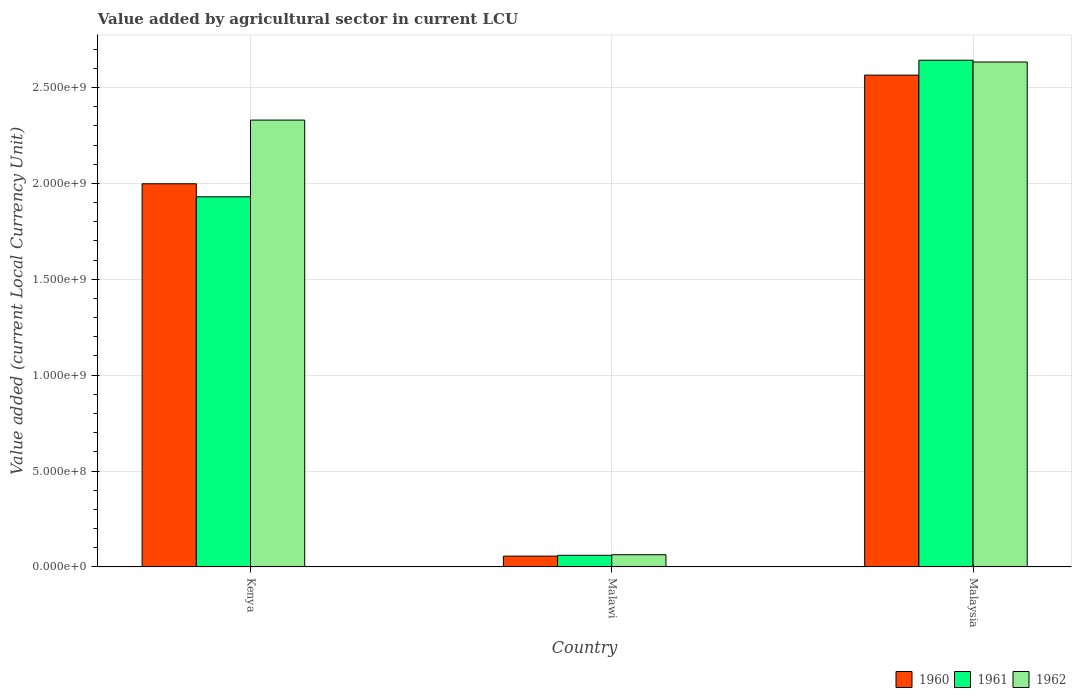How many bars are there on the 2nd tick from the left?
Provide a short and direct response. 3. How many bars are there on the 1st tick from the right?
Your response must be concise. 3. What is the label of the 3rd group of bars from the left?
Give a very brief answer. Malaysia. What is the value added by agricultural sector in 1961 in Malaysia?
Keep it short and to the point. 2.64e+09. Across all countries, what is the maximum value added by agricultural sector in 1960?
Your answer should be very brief. 2.56e+09. Across all countries, what is the minimum value added by agricultural sector in 1962?
Keep it short and to the point. 6.36e+07. In which country was the value added by agricultural sector in 1962 maximum?
Your response must be concise. Malaysia. In which country was the value added by agricultural sector in 1962 minimum?
Offer a very short reply. Malawi. What is the total value added by agricultural sector in 1960 in the graph?
Ensure brevity in your answer.  4.62e+09. What is the difference between the value added by agricultural sector in 1961 in Kenya and that in Malawi?
Provide a succinct answer. 1.87e+09. What is the difference between the value added by agricultural sector in 1961 in Malaysia and the value added by agricultural sector in 1960 in Malawi?
Provide a succinct answer. 2.59e+09. What is the average value added by agricultural sector in 1960 per country?
Make the answer very short. 1.54e+09. What is the difference between the value added by agricultural sector of/in 1962 and value added by agricultural sector of/in 1960 in Malawi?
Your response must be concise. 7.30e+06. What is the ratio of the value added by agricultural sector in 1962 in Kenya to that in Malaysia?
Your response must be concise. 0.88. Is the value added by agricultural sector in 1961 in Kenya less than that in Malawi?
Ensure brevity in your answer.  No. Is the difference between the value added by agricultural sector in 1962 in Kenya and Malawi greater than the difference between the value added by agricultural sector in 1960 in Kenya and Malawi?
Keep it short and to the point. Yes. What is the difference between the highest and the second highest value added by agricultural sector in 1961?
Ensure brevity in your answer.  -7.12e+08. What is the difference between the highest and the lowest value added by agricultural sector in 1962?
Your answer should be very brief. 2.57e+09. In how many countries, is the value added by agricultural sector in 1960 greater than the average value added by agricultural sector in 1960 taken over all countries?
Your response must be concise. 2. What does the 1st bar from the left in Malaysia represents?
Keep it short and to the point. 1960. What does the 2nd bar from the right in Malawi represents?
Provide a succinct answer. 1961. Are all the bars in the graph horizontal?
Offer a very short reply. No. What is the difference between two consecutive major ticks on the Y-axis?
Make the answer very short. 5.00e+08. Are the values on the major ticks of Y-axis written in scientific E-notation?
Provide a short and direct response. Yes. How are the legend labels stacked?
Your answer should be compact. Horizontal. What is the title of the graph?
Provide a succinct answer. Value added by agricultural sector in current LCU. Does "2002" appear as one of the legend labels in the graph?
Provide a short and direct response. No. What is the label or title of the X-axis?
Ensure brevity in your answer.  Country. What is the label or title of the Y-axis?
Your answer should be very brief. Value added (current Local Currency Unit). What is the Value added (current Local Currency Unit) in 1960 in Kenya?
Offer a very short reply. 2.00e+09. What is the Value added (current Local Currency Unit) of 1961 in Kenya?
Your answer should be very brief. 1.93e+09. What is the Value added (current Local Currency Unit) in 1962 in Kenya?
Your answer should be very brief. 2.33e+09. What is the Value added (current Local Currency Unit) in 1960 in Malawi?
Provide a short and direct response. 5.63e+07. What is the Value added (current Local Currency Unit) in 1961 in Malawi?
Provide a succinct answer. 6.06e+07. What is the Value added (current Local Currency Unit) in 1962 in Malawi?
Offer a very short reply. 6.36e+07. What is the Value added (current Local Currency Unit) of 1960 in Malaysia?
Your answer should be very brief. 2.56e+09. What is the Value added (current Local Currency Unit) in 1961 in Malaysia?
Ensure brevity in your answer.  2.64e+09. What is the Value added (current Local Currency Unit) in 1962 in Malaysia?
Offer a terse response. 2.63e+09. Across all countries, what is the maximum Value added (current Local Currency Unit) of 1960?
Provide a succinct answer. 2.56e+09. Across all countries, what is the maximum Value added (current Local Currency Unit) in 1961?
Provide a succinct answer. 2.64e+09. Across all countries, what is the maximum Value added (current Local Currency Unit) of 1962?
Offer a terse response. 2.63e+09. Across all countries, what is the minimum Value added (current Local Currency Unit) of 1960?
Provide a succinct answer. 5.63e+07. Across all countries, what is the minimum Value added (current Local Currency Unit) of 1961?
Your response must be concise. 6.06e+07. Across all countries, what is the minimum Value added (current Local Currency Unit) in 1962?
Your answer should be compact. 6.36e+07. What is the total Value added (current Local Currency Unit) of 1960 in the graph?
Your response must be concise. 4.62e+09. What is the total Value added (current Local Currency Unit) of 1961 in the graph?
Keep it short and to the point. 4.63e+09. What is the total Value added (current Local Currency Unit) of 1962 in the graph?
Provide a succinct answer. 5.03e+09. What is the difference between the Value added (current Local Currency Unit) of 1960 in Kenya and that in Malawi?
Offer a terse response. 1.94e+09. What is the difference between the Value added (current Local Currency Unit) of 1961 in Kenya and that in Malawi?
Make the answer very short. 1.87e+09. What is the difference between the Value added (current Local Currency Unit) of 1962 in Kenya and that in Malawi?
Your answer should be very brief. 2.27e+09. What is the difference between the Value added (current Local Currency Unit) of 1960 in Kenya and that in Malaysia?
Ensure brevity in your answer.  -5.67e+08. What is the difference between the Value added (current Local Currency Unit) of 1961 in Kenya and that in Malaysia?
Your answer should be compact. -7.12e+08. What is the difference between the Value added (current Local Currency Unit) in 1962 in Kenya and that in Malaysia?
Give a very brief answer. -3.03e+08. What is the difference between the Value added (current Local Currency Unit) in 1960 in Malawi and that in Malaysia?
Keep it short and to the point. -2.51e+09. What is the difference between the Value added (current Local Currency Unit) in 1961 in Malawi and that in Malaysia?
Give a very brief answer. -2.58e+09. What is the difference between the Value added (current Local Currency Unit) of 1962 in Malawi and that in Malaysia?
Your response must be concise. -2.57e+09. What is the difference between the Value added (current Local Currency Unit) in 1960 in Kenya and the Value added (current Local Currency Unit) in 1961 in Malawi?
Keep it short and to the point. 1.94e+09. What is the difference between the Value added (current Local Currency Unit) in 1960 in Kenya and the Value added (current Local Currency Unit) in 1962 in Malawi?
Your answer should be very brief. 1.93e+09. What is the difference between the Value added (current Local Currency Unit) in 1961 in Kenya and the Value added (current Local Currency Unit) in 1962 in Malawi?
Make the answer very short. 1.87e+09. What is the difference between the Value added (current Local Currency Unit) in 1960 in Kenya and the Value added (current Local Currency Unit) in 1961 in Malaysia?
Make the answer very short. -6.44e+08. What is the difference between the Value added (current Local Currency Unit) in 1960 in Kenya and the Value added (current Local Currency Unit) in 1962 in Malaysia?
Offer a very short reply. -6.35e+08. What is the difference between the Value added (current Local Currency Unit) of 1961 in Kenya and the Value added (current Local Currency Unit) of 1962 in Malaysia?
Your answer should be compact. -7.03e+08. What is the difference between the Value added (current Local Currency Unit) of 1960 in Malawi and the Value added (current Local Currency Unit) of 1961 in Malaysia?
Your answer should be very brief. -2.59e+09. What is the difference between the Value added (current Local Currency Unit) in 1960 in Malawi and the Value added (current Local Currency Unit) in 1962 in Malaysia?
Your response must be concise. -2.58e+09. What is the difference between the Value added (current Local Currency Unit) in 1961 in Malawi and the Value added (current Local Currency Unit) in 1962 in Malaysia?
Your answer should be compact. -2.57e+09. What is the average Value added (current Local Currency Unit) in 1960 per country?
Keep it short and to the point. 1.54e+09. What is the average Value added (current Local Currency Unit) in 1961 per country?
Your response must be concise. 1.54e+09. What is the average Value added (current Local Currency Unit) of 1962 per country?
Provide a succinct answer. 1.68e+09. What is the difference between the Value added (current Local Currency Unit) of 1960 and Value added (current Local Currency Unit) of 1961 in Kenya?
Provide a short and direct response. 6.79e+07. What is the difference between the Value added (current Local Currency Unit) of 1960 and Value added (current Local Currency Unit) of 1962 in Kenya?
Offer a very short reply. -3.32e+08. What is the difference between the Value added (current Local Currency Unit) of 1961 and Value added (current Local Currency Unit) of 1962 in Kenya?
Offer a terse response. -4.00e+08. What is the difference between the Value added (current Local Currency Unit) of 1960 and Value added (current Local Currency Unit) of 1961 in Malawi?
Offer a very short reply. -4.30e+06. What is the difference between the Value added (current Local Currency Unit) of 1960 and Value added (current Local Currency Unit) of 1962 in Malawi?
Provide a short and direct response. -7.30e+06. What is the difference between the Value added (current Local Currency Unit) of 1960 and Value added (current Local Currency Unit) of 1961 in Malaysia?
Offer a terse response. -7.78e+07. What is the difference between the Value added (current Local Currency Unit) of 1960 and Value added (current Local Currency Unit) of 1962 in Malaysia?
Give a very brief answer. -6.83e+07. What is the difference between the Value added (current Local Currency Unit) in 1961 and Value added (current Local Currency Unit) in 1962 in Malaysia?
Offer a terse response. 9.46e+06. What is the ratio of the Value added (current Local Currency Unit) of 1960 in Kenya to that in Malawi?
Your response must be concise. 35.48. What is the ratio of the Value added (current Local Currency Unit) in 1961 in Kenya to that in Malawi?
Provide a succinct answer. 31.85. What is the ratio of the Value added (current Local Currency Unit) in 1962 in Kenya to that in Malawi?
Provide a succinct answer. 36.63. What is the ratio of the Value added (current Local Currency Unit) in 1960 in Kenya to that in Malaysia?
Offer a terse response. 0.78. What is the ratio of the Value added (current Local Currency Unit) of 1961 in Kenya to that in Malaysia?
Provide a succinct answer. 0.73. What is the ratio of the Value added (current Local Currency Unit) in 1962 in Kenya to that in Malaysia?
Your answer should be very brief. 0.89. What is the ratio of the Value added (current Local Currency Unit) of 1960 in Malawi to that in Malaysia?
Offer a terse response. 0.02. What is the ratio of the Value added (current Local Currency Unit) of 1961 in Malawi to that in Malaysia?
Your answer should be very brief. 0.02. What is the ratio of the Value added (current Local Currency Unit) of 1962 in Malawi to that in Malaysia?
Provide a short and direct response. 0.02. What is the difference between the highest and the second highest Value added (current Local Currency Unit) in 1960?
Your response must be concise. 5.67e+08. What is the difference between the highest and the second highest Value added (current Local Currency Unit) in 1961?
Ensure brevity in your answer.  7.12e+08. What is the difference between the highest and the second highest Value added (current Local Currency Unit) of 1962?
Ensure brevity in your answer.  3.03e+08. What is the difference between the highest and the lowest Value added (current Local Currency Unit) in 1960?
Keep it short and to the point. 2.51e+09. What is the difference between the highest and the lowest Value added (current Local Currency Unit) in 1961?
Offer a very short reply. 2.58e+09. What is the difference between the highest and the lowest Value added (current Local Currency Unit) of 1962?
Provide a succinct answer. 2.57e+09. 